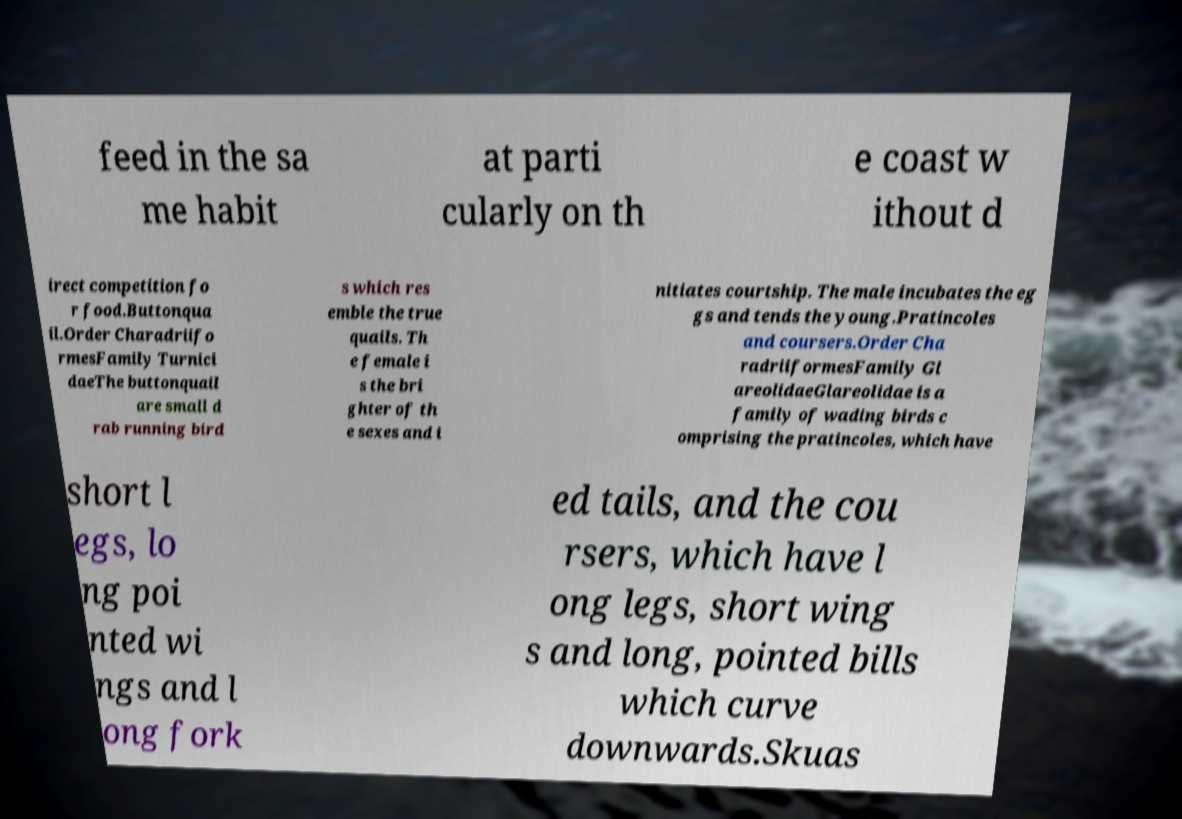I need the written content from this picture converted into text. Can you do that? feed in the sa me habit at parti cularly on th e coast w ithout d irect competition fo r food.Buttonqua il.Order Charadriifo rmesFamily Turnici daeThe buttonquail are small d rab running bird s which res emble the true quails. Th e female i s the bri ghter of th e sexes and i nitiates courtship. The male incubates the eg gs and tends the young.Pratincoles and coursers.Order Cha radriiformesFamily Gl areolidaeGlareolidae is a family of wading birds c omprising the pratincoles, which have short l egs, lo ng poi nted wi ngs and l ong fork ed tails, and the cou rsers, which have l ong legs, short wing s and long, pointed bills which curve downwards.Skuas 